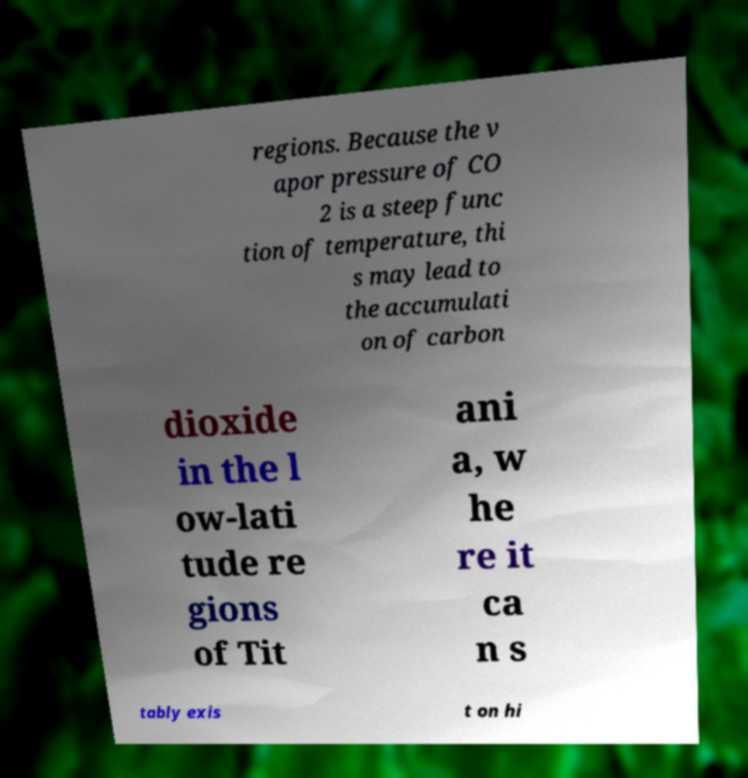What messages or text are displayed in this image? I need them in a readable, typed format. regions. Because the v apor pressure of CO 2 is a steep func tion of temperature, thi s may lead to the accumulati on of carbon dioxide in the l ow-lati tude re gions of Tit ani a, w he re it ca n s tably exis t on hi 